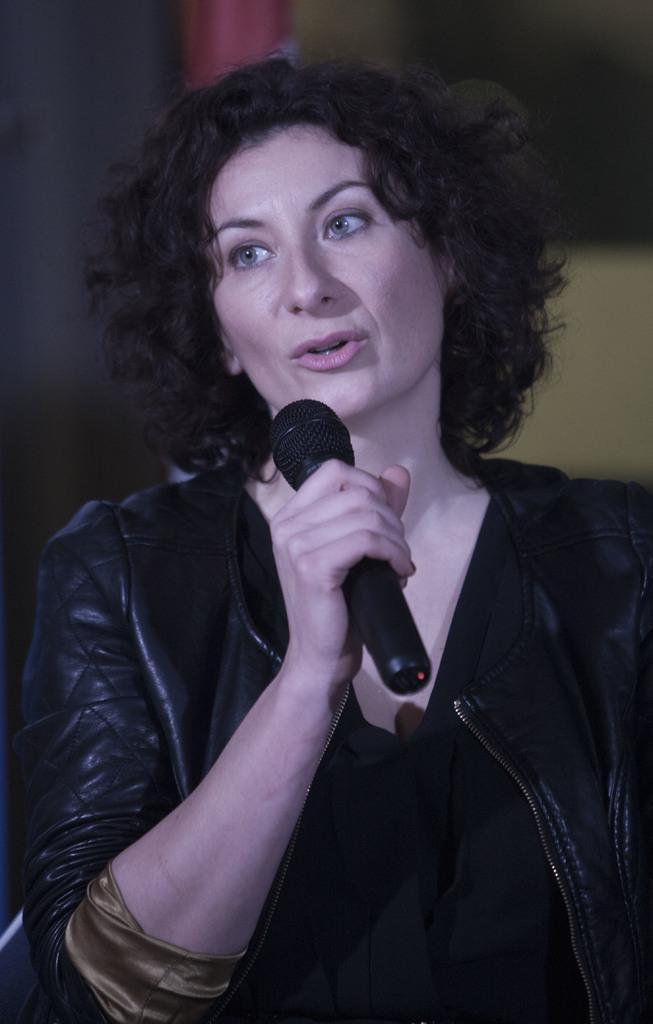Could you give a brief overview of what you see in this image? This image consist of a woman and holding a mike and her mouth is open and wearing a black color jacket. 